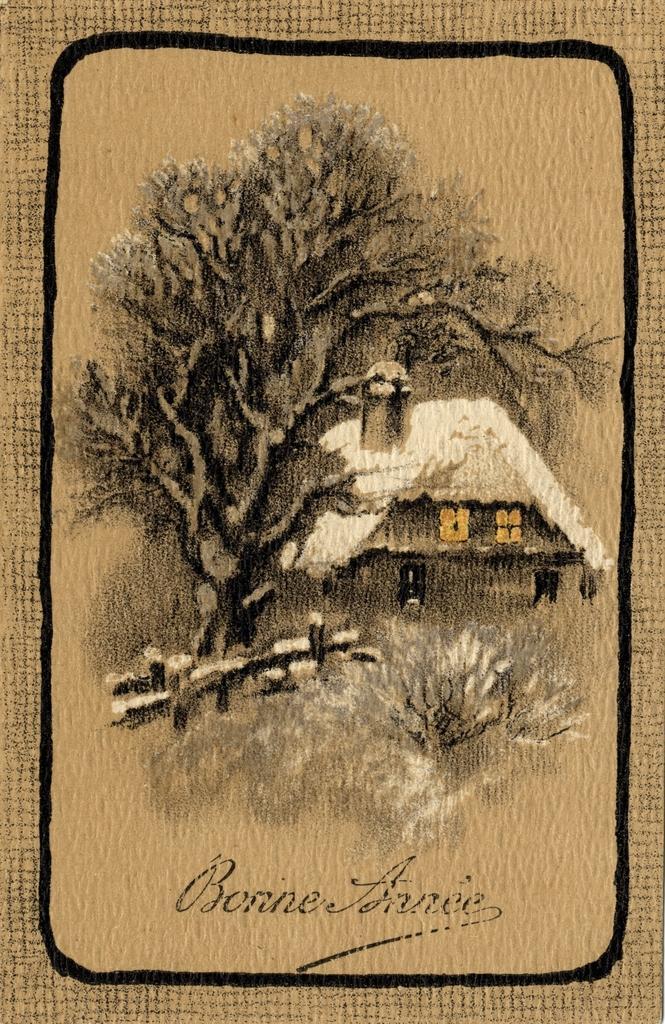In one or two sentences, can you explain what this image depicts? In this image we can see a painting of a house, tree and there is some text. 